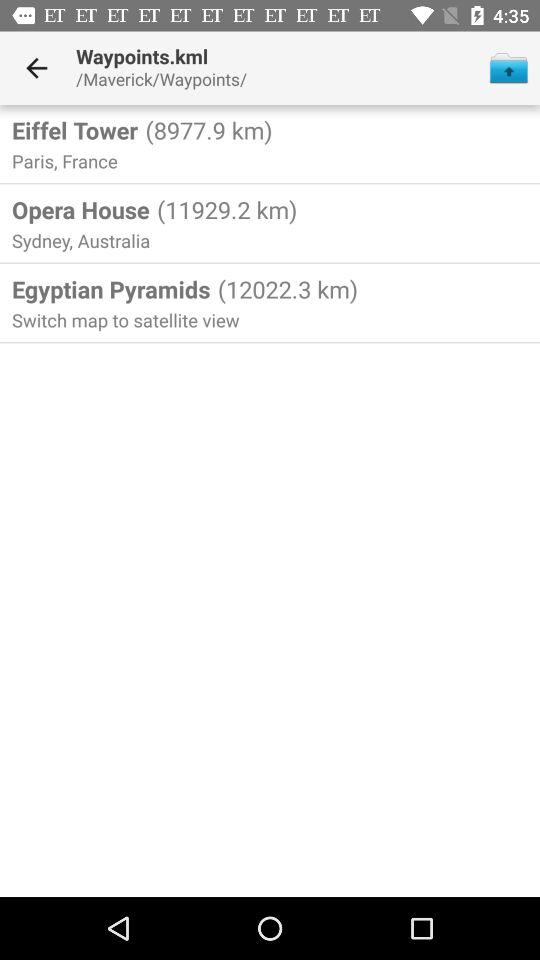What is the distance to the "Eiffel Tower"? The distance to the "Eiffel Tower" is 8977.9 km. 